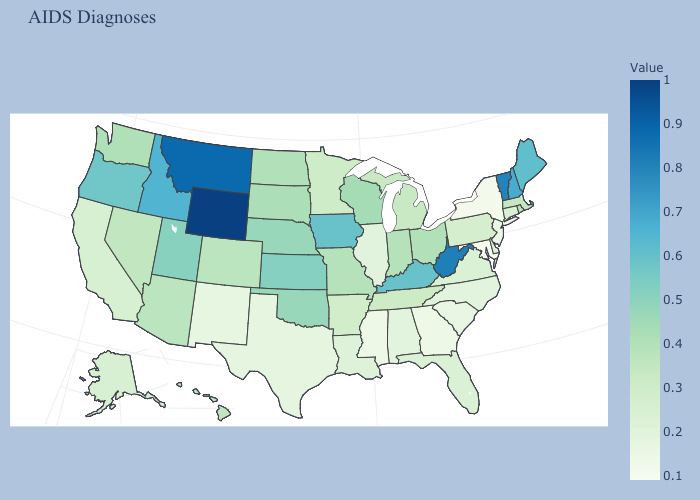Among the states that border New Hampshire , which have the lowest value?
Give a very brief answer. Massachusetts. Which states have the lowest value in the South?
Answer briefly. Maryland. Does the map have missing data?
Short answer required. No. Among the states that border Ohio , which have the highest value?
Concise answer only. West Virginia. Is the legend a continuous bar?
Quick response, please. Yes. Does Kentucky have the lowest value in the South?
Be succinct. No. Does Wyoming have the highest value in the USA?
Quick response, please. Yes. 